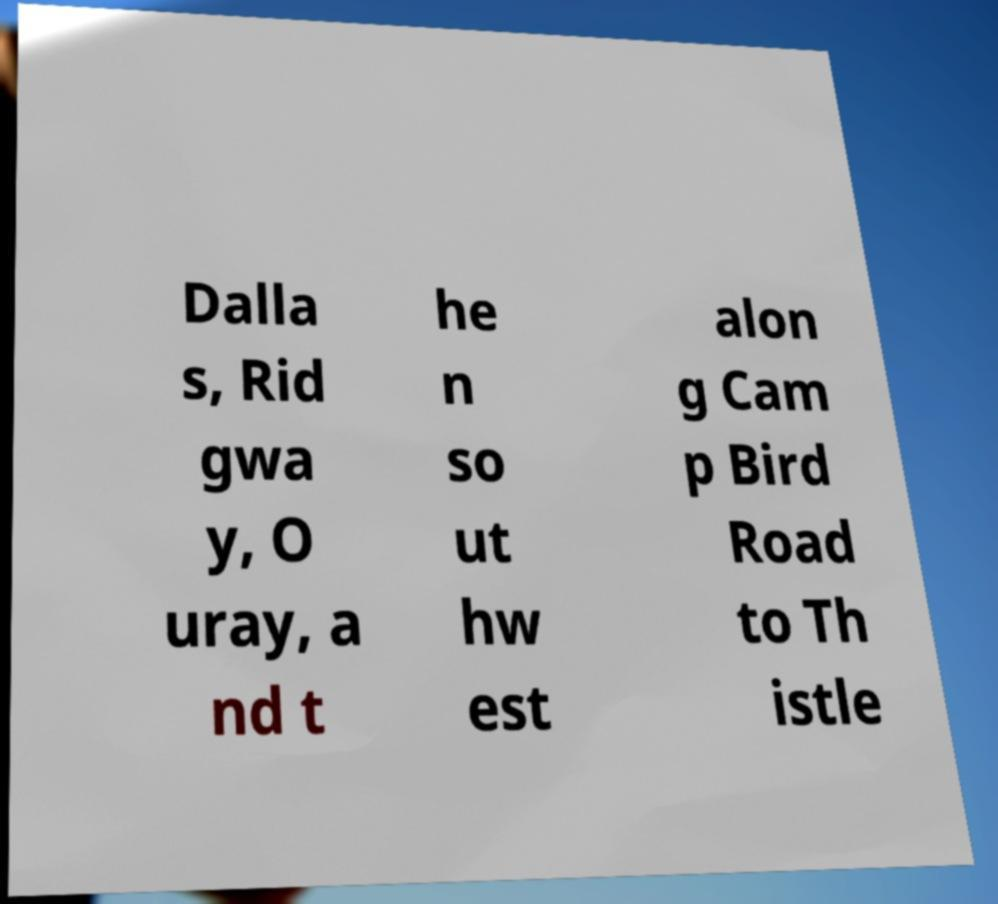What messages or text are displayed in this image? I need them in a readable, typed format. Dalla s, Rid gwa y, O uray, a nd t he n so ut hw est alon g Cam p Bird Road to Th istle 